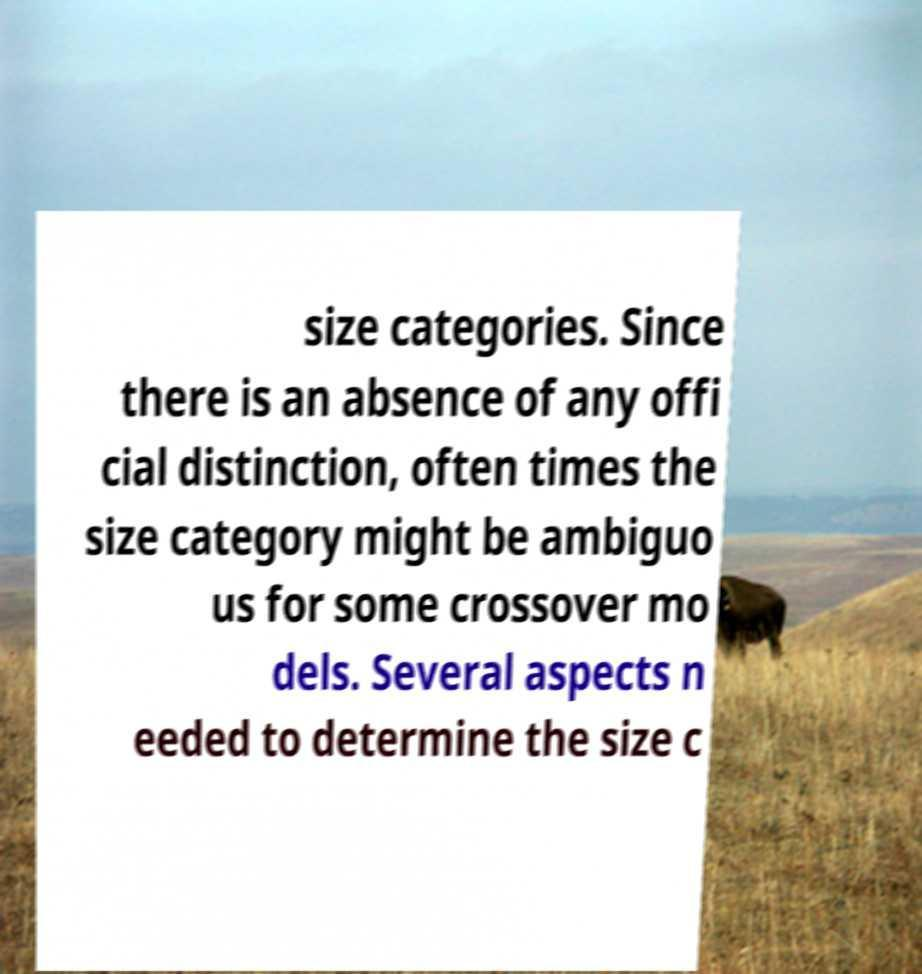I need the written content from this picture converted into text. Can you do that? size categories. Since there is an absence of any offi cial distinction, often times the size category might be ambiguo us for some crossover mo dels. Several aspects n eeded to determine the size c 